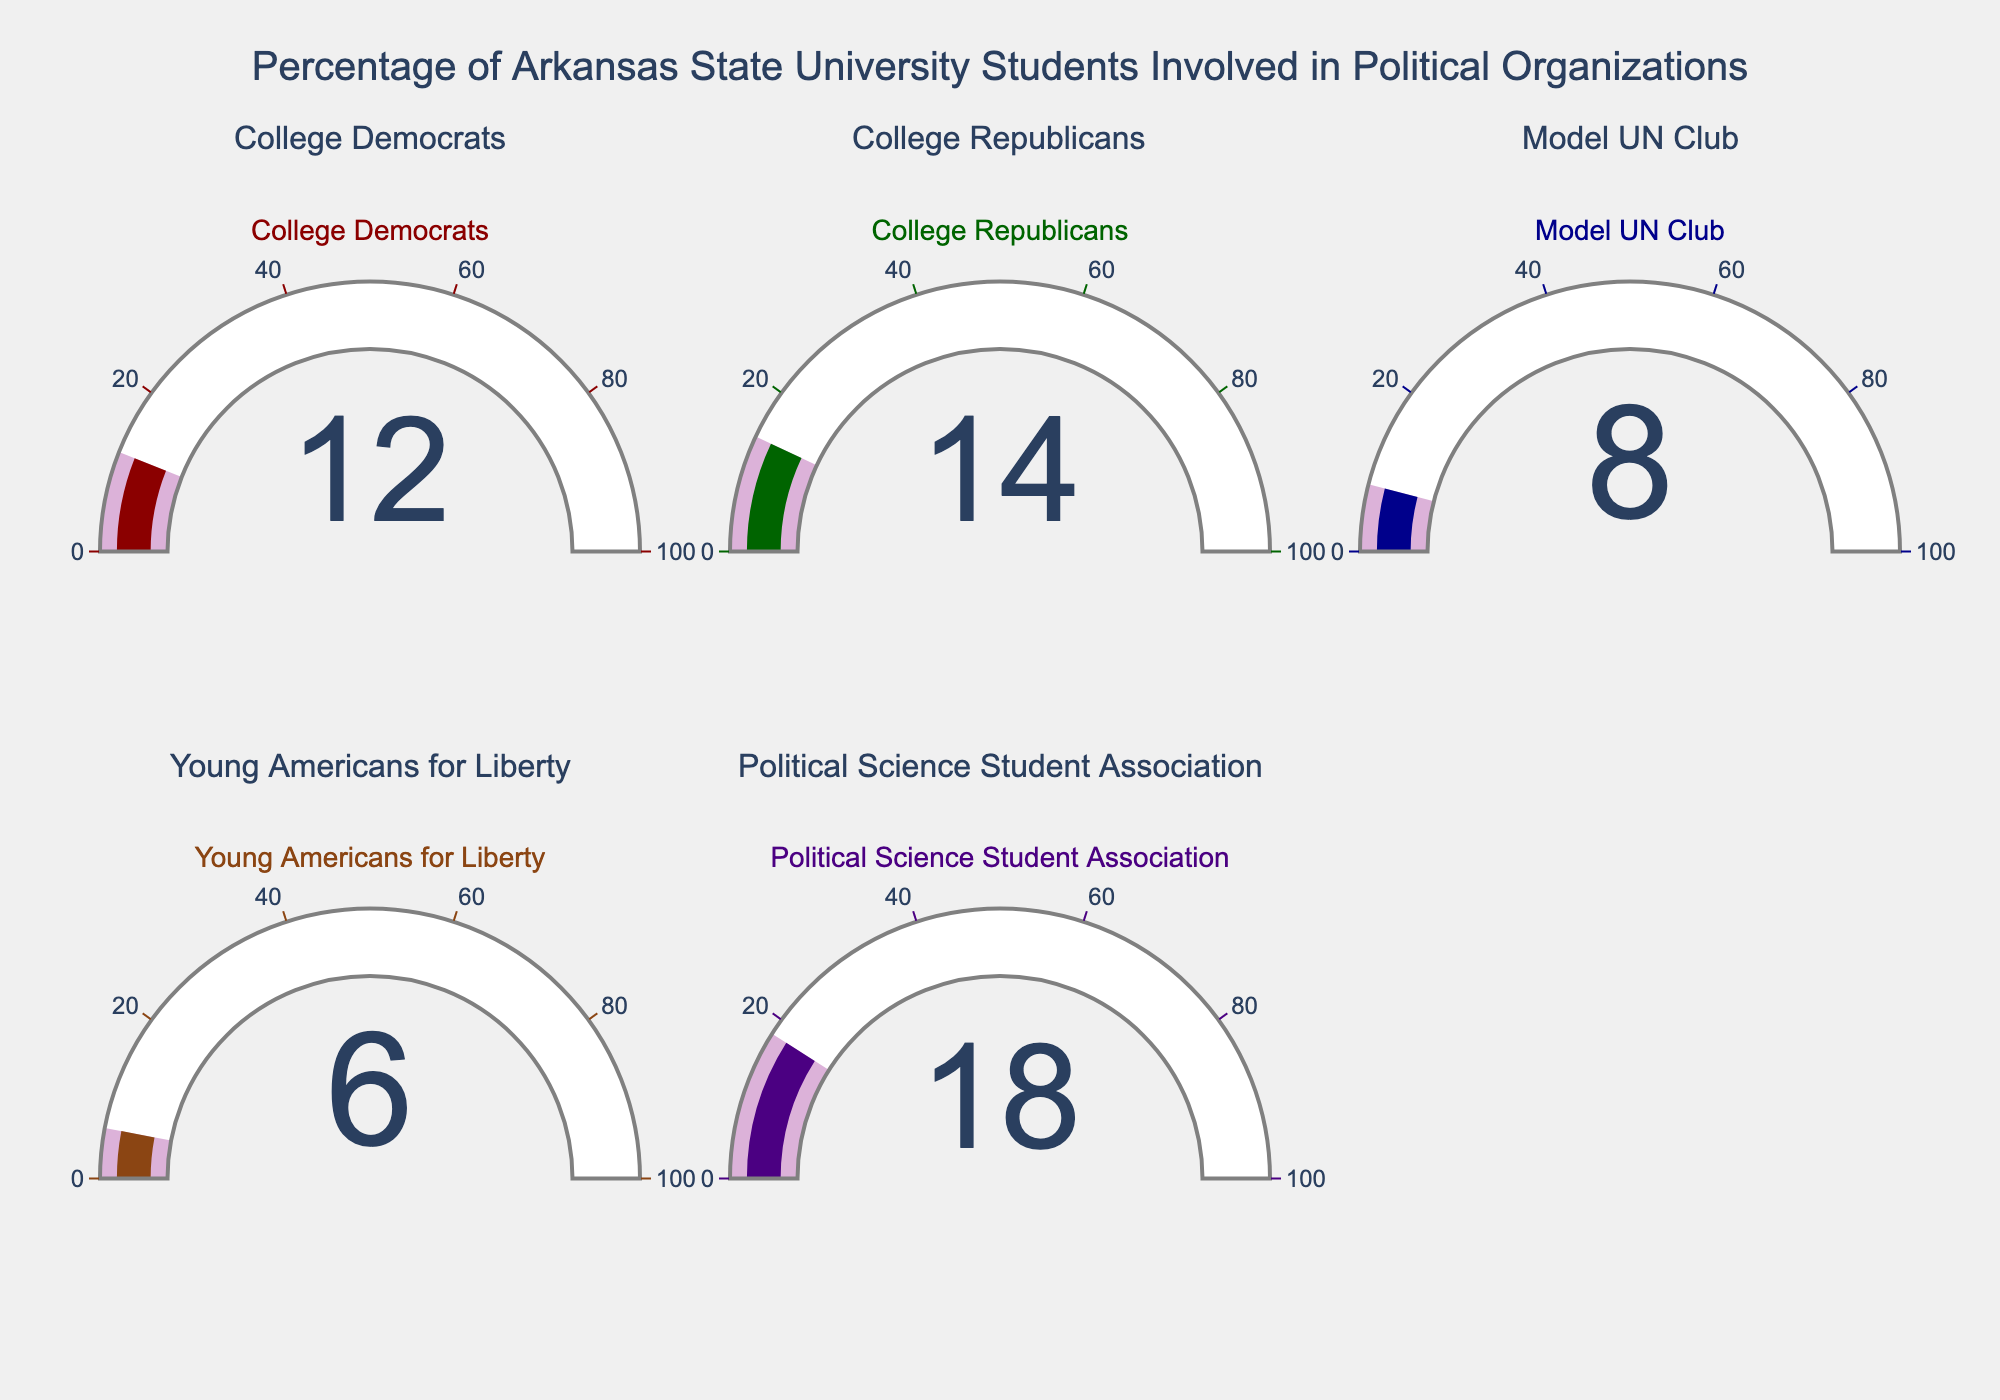How many political organizations are displayed in the figure? To find the answer, count the number of gauge charts or subplots present in the figure.
Answer: 5 What is the title of the figure? The title is usually displayed prominently at the top of the figure.
Answer: Percentage of Arkansas State University Students Involved in Political Organizations Which organization has the highest percentage of student involvement? Compare the percentage values displayed on each gauge chart.
Answer: Political Science Student Association What is the difference in student involvement between College Democrats and College Republicans? Subtract the percentage of College Democrats (12%) from the percentage of College Republicans (14%).
Answer: 2% What is the average percentage of student involvement across all organizations? To find the average, sum all percentages (12% + 14% + 8% + 6% + 18%) to get 58%, then divide by the number of organizations (5).
Answer: 11.6% Which organizations have student involvement less than 10%? Identify organizations with percentage values below 10% on their gauge charts.
Answer: Model UN Club, Young Americans for Liberty What is the combined percentage of student involvement for the Model UN Club and Young Americans for Liberty? Add the percentage values for the Model UN Club (8%) and Young Americans for Liberty (6%).
Answer: 14% How does the involvement in the Political Science Student Association compare to the average involvement across all organizations? The Political Science Student Association has 18% involvement. The average involvement calculated earlier is 11.6%. Compare these two values to see that 18% is greater than 11.6%.
Answer: Greater Are there any gauge charts where the displayed percentage is the exact same value? Examine each gauge chart to see if any have identical percentage values.
Answer: No Which organization has the lowest student involvement? Identify the gauge chart with the smallest percentage value.
Answer: Young Americans for Liberty 